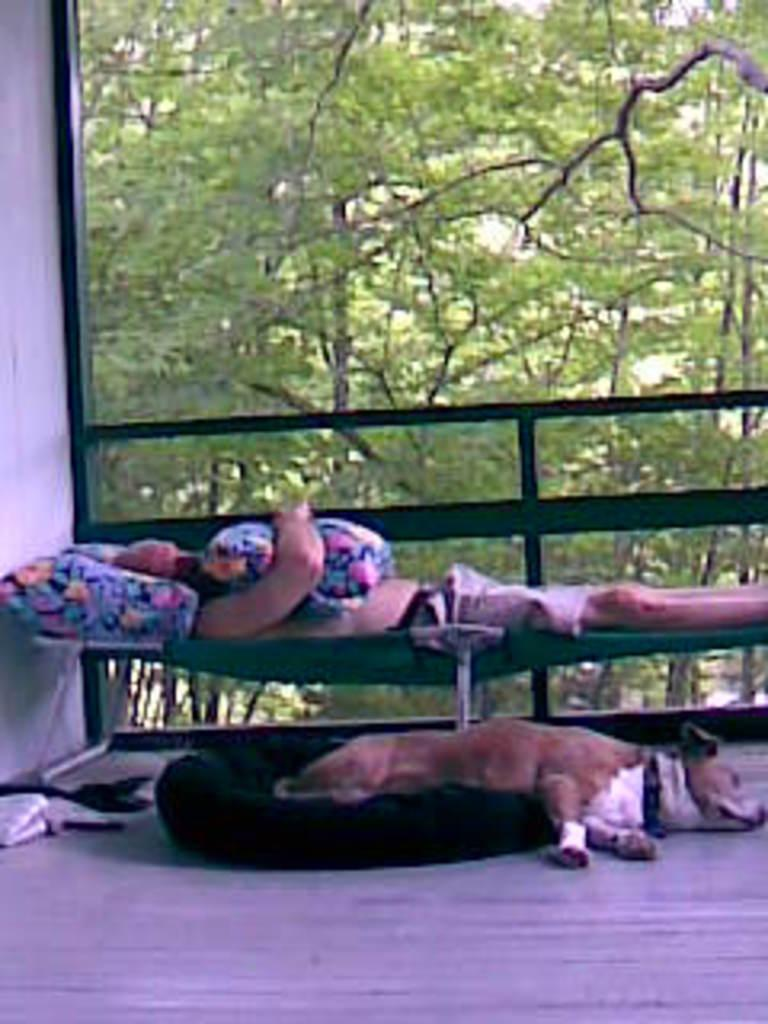What type of animal can be seen in the image? There is a dog in the image. What objects are present in the image that might be used for comfort or relaxation? There are pillows in the image. What is the man in the image doing? A man is sleeping on a bed in the image. What can be seen in the background of the image? There are trees visible in the image. What color are the eyes of the mailbox in the image? There is no mailbox present in the image, so it is not possible to determine the color of its eyes. 